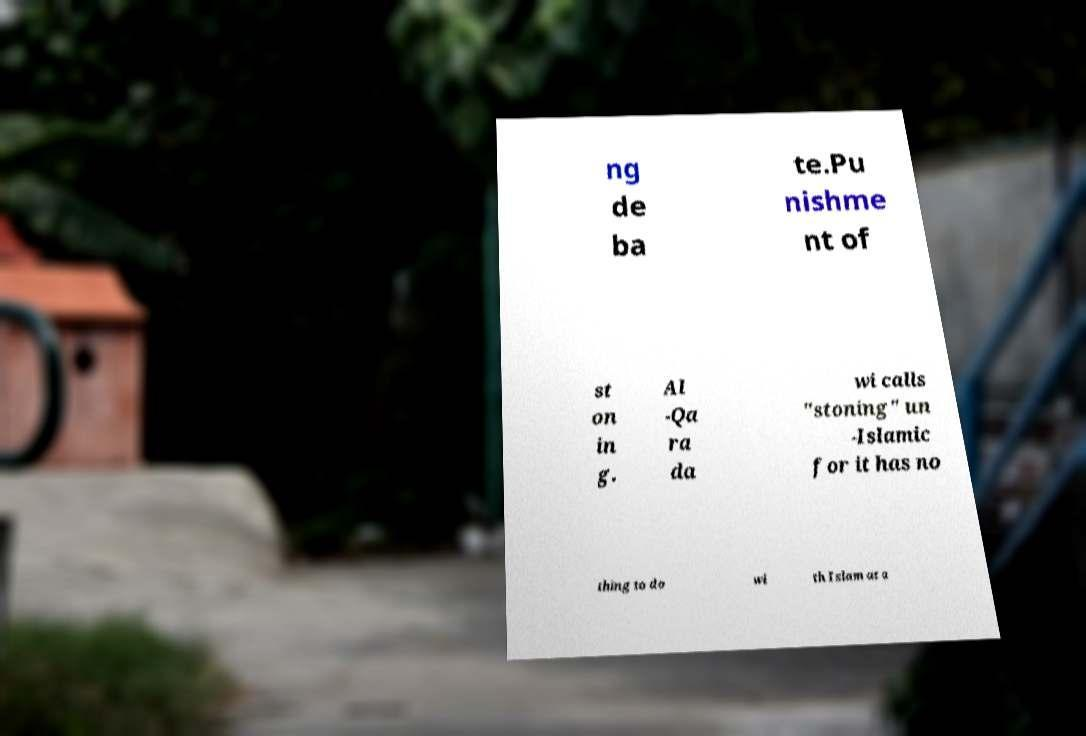What messages or text are displayed in this image? I need them in a readable, typed format. ng de ba te.Pu nishme nt of st on in g. Al -Qa ra da wi calls "stoning" un -Islamic for it has no thing to do wi th Islam at a 